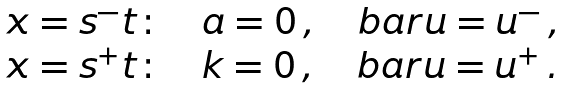<formula> <loc_0><loc_0><loc_500><loc_500>\begin{array} { l } x = s ^ { - } t \colon \quad a = 0 \, , \quad b a r u = u ^ { - } \, , \\ x = s ^ { + } t \colon \quad k = 0 \, , \quad b a r u = u ^ { + } \, . \end{array}</formula> 